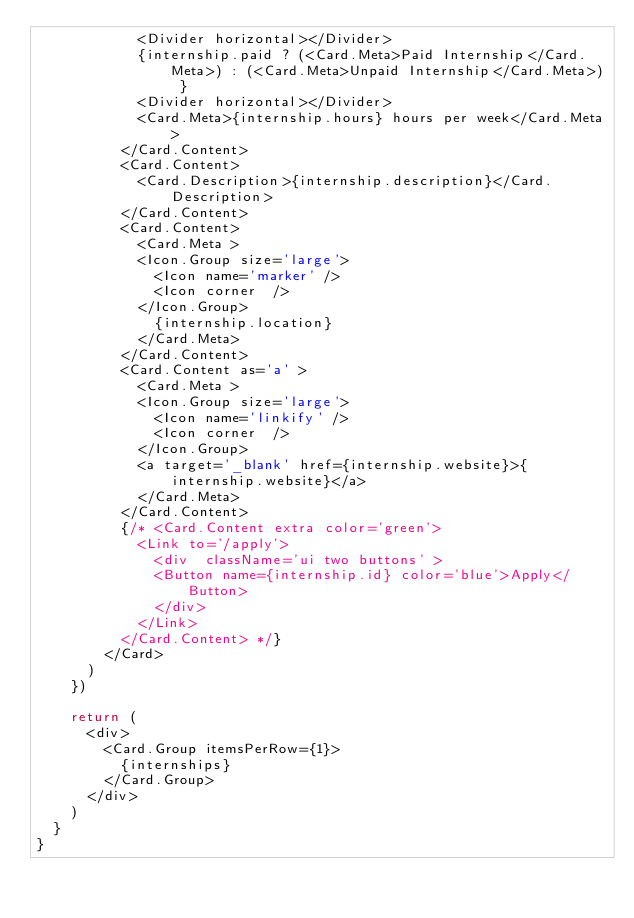Convert code to text. <code><loc_0><loc_0><loc_500><loc_500><_JavaScript_>            <Divider horizontal></Divider>
            {internship.paid ? (<Card.Meta>Paid Internship</Card.Meta>) : (<Card.Meta>Unpaid Internship</Card.Meta>) }
            <Divider horizontal></Divider>
            <Card.Meta>{internship.hours} hours per week</Card.Meta>
          </Card.Content>
          <Card.Content>
            <Card.Description>{internship.description}</Card.Description>
          </Card.Content>
          <Card.Content>
            <Card.Meta >
            <Icon.Group size='large'>
              <Icon name='marker' />
              <Icon corner  />
            </Icon.Group>
              {internship.location}
            </Card.Meta>
          </Card.Content>
          <Card.Content as='a' >
            <Card.Meta >
            <Icon.Group size='large'>
              <Icon name='linkify' />
              <Icon corner  />
            </Icon.Group>
            <a target='_blank' href={internship.website}>{internship.website}</a>
            </Card.Meta>
          </Card.Content>
          {/* <Card.Content extra color='green'>
            <Link to='/apply'>
              <div  className='ui two buttons' >
              <Button name={internship.id} color='blue'>Apply</Button>
              </div>
            </Link>
          </Card.Content> */}
        </Card>
      ) 
    })

    return (
      <div>
        <Card.Group itemsPerRow={1}>
          {internships}
        </Card.Group>
      </div>
    )
  }
}</code> 